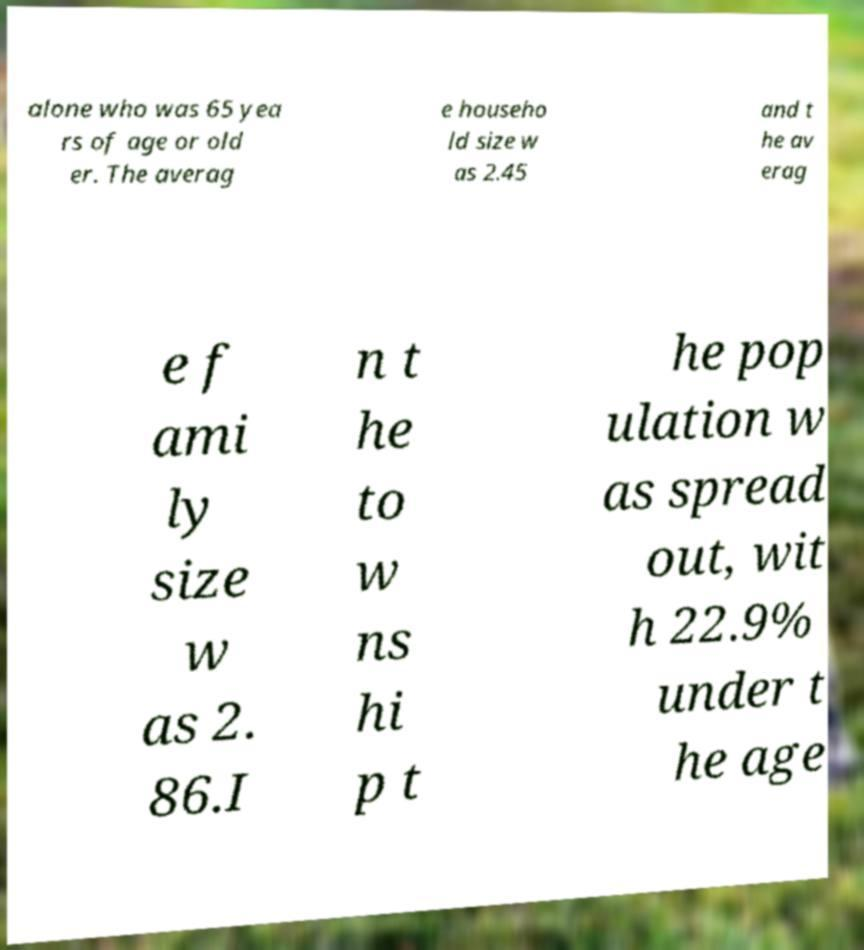Could you extract and type out the text from this image? alone who was 65 yea rs of age or old er. The averag e househo ld size w as 2.45 and t he av erag e f ami ly size w as 2. 86.I n t he to w ns hi p t he pop ulation w as spread out, wit h 22.9% under t he age 